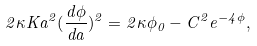<formula> <loc_0><loc_0><loc_500><loc_500>2 \kappa K a ^ { 2 } ( \frac { d \phi } { d a } ) ^ { 2 } = 2 \kappa \phi _ { 0 } - C ^ { 2 } e ^ { - 4 \phi } ,</formula> 